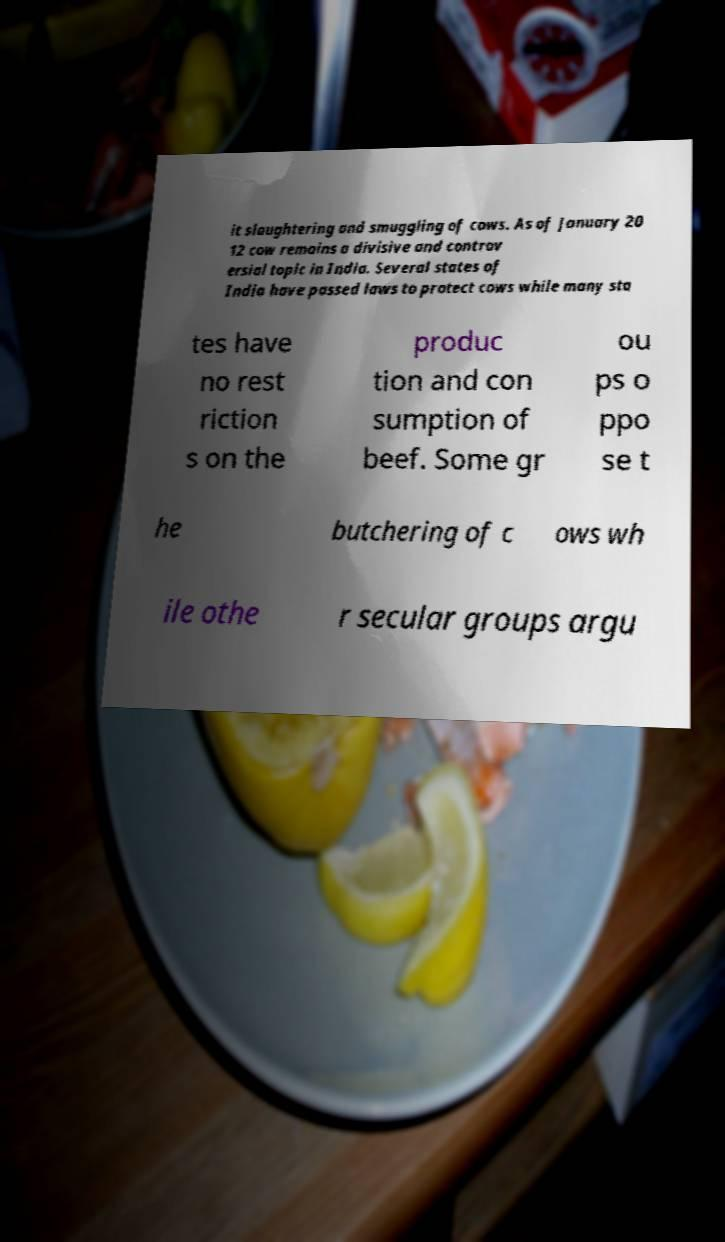For documentation purposes, I need the text within this image transcribed. Could you provide that? it slaughtering and smuggling of cows. As of January 20 12 cow remains a divisive and controv ersial topic in India. Several states of India have passed laws to protect cows while many sta tes have no rest riction s on the produc tion and con sumption of beef. Some gr ou ps o ppo se t he butchering of c ows wh ile othe r secular groups argu 